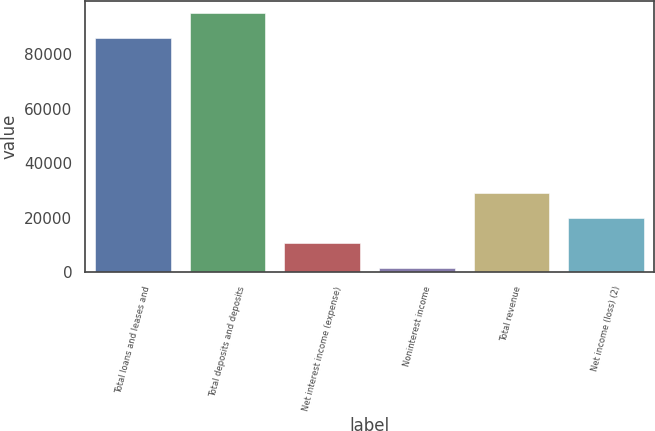<chart> <loc_0><loc_0><loc_500><loc_500><bar_chart><fcel>Total loans and leases and<fcel>Total deposits and deposits<fcel>Net interest income (expense)<fcel>Noninterest income<fcel>Total revenue<fcel>Net income (loss) (2)<nl><fcel>85797<fcel>94967.4<fcel>10802.4<fcel>1632<fcel>29143.2<fcel>19972.8<nl></chart> 